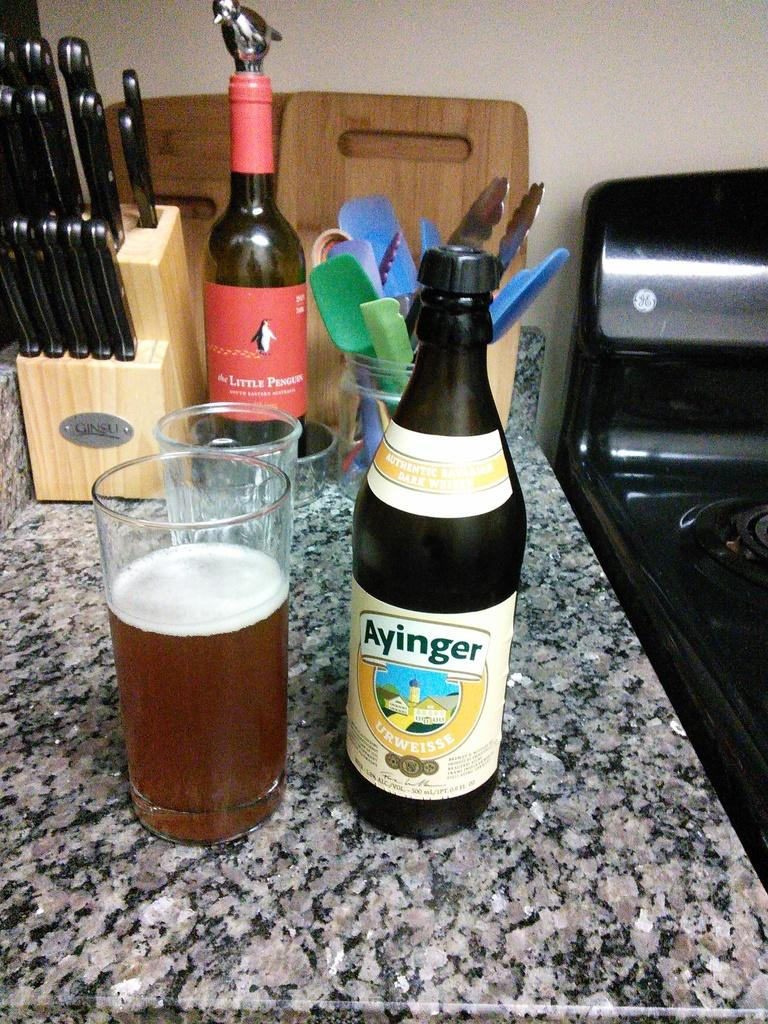<image>
Summarize the visual content of the image. A bottle of Ayinger is on a counter next to a full glass. 